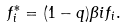Convert formula to latex. <formula><loc_0><loc_0><loc_500><loc_500>f ^ { * } _ { i } = ( 1 - q ) \beta i f _ { i } .</formula> 